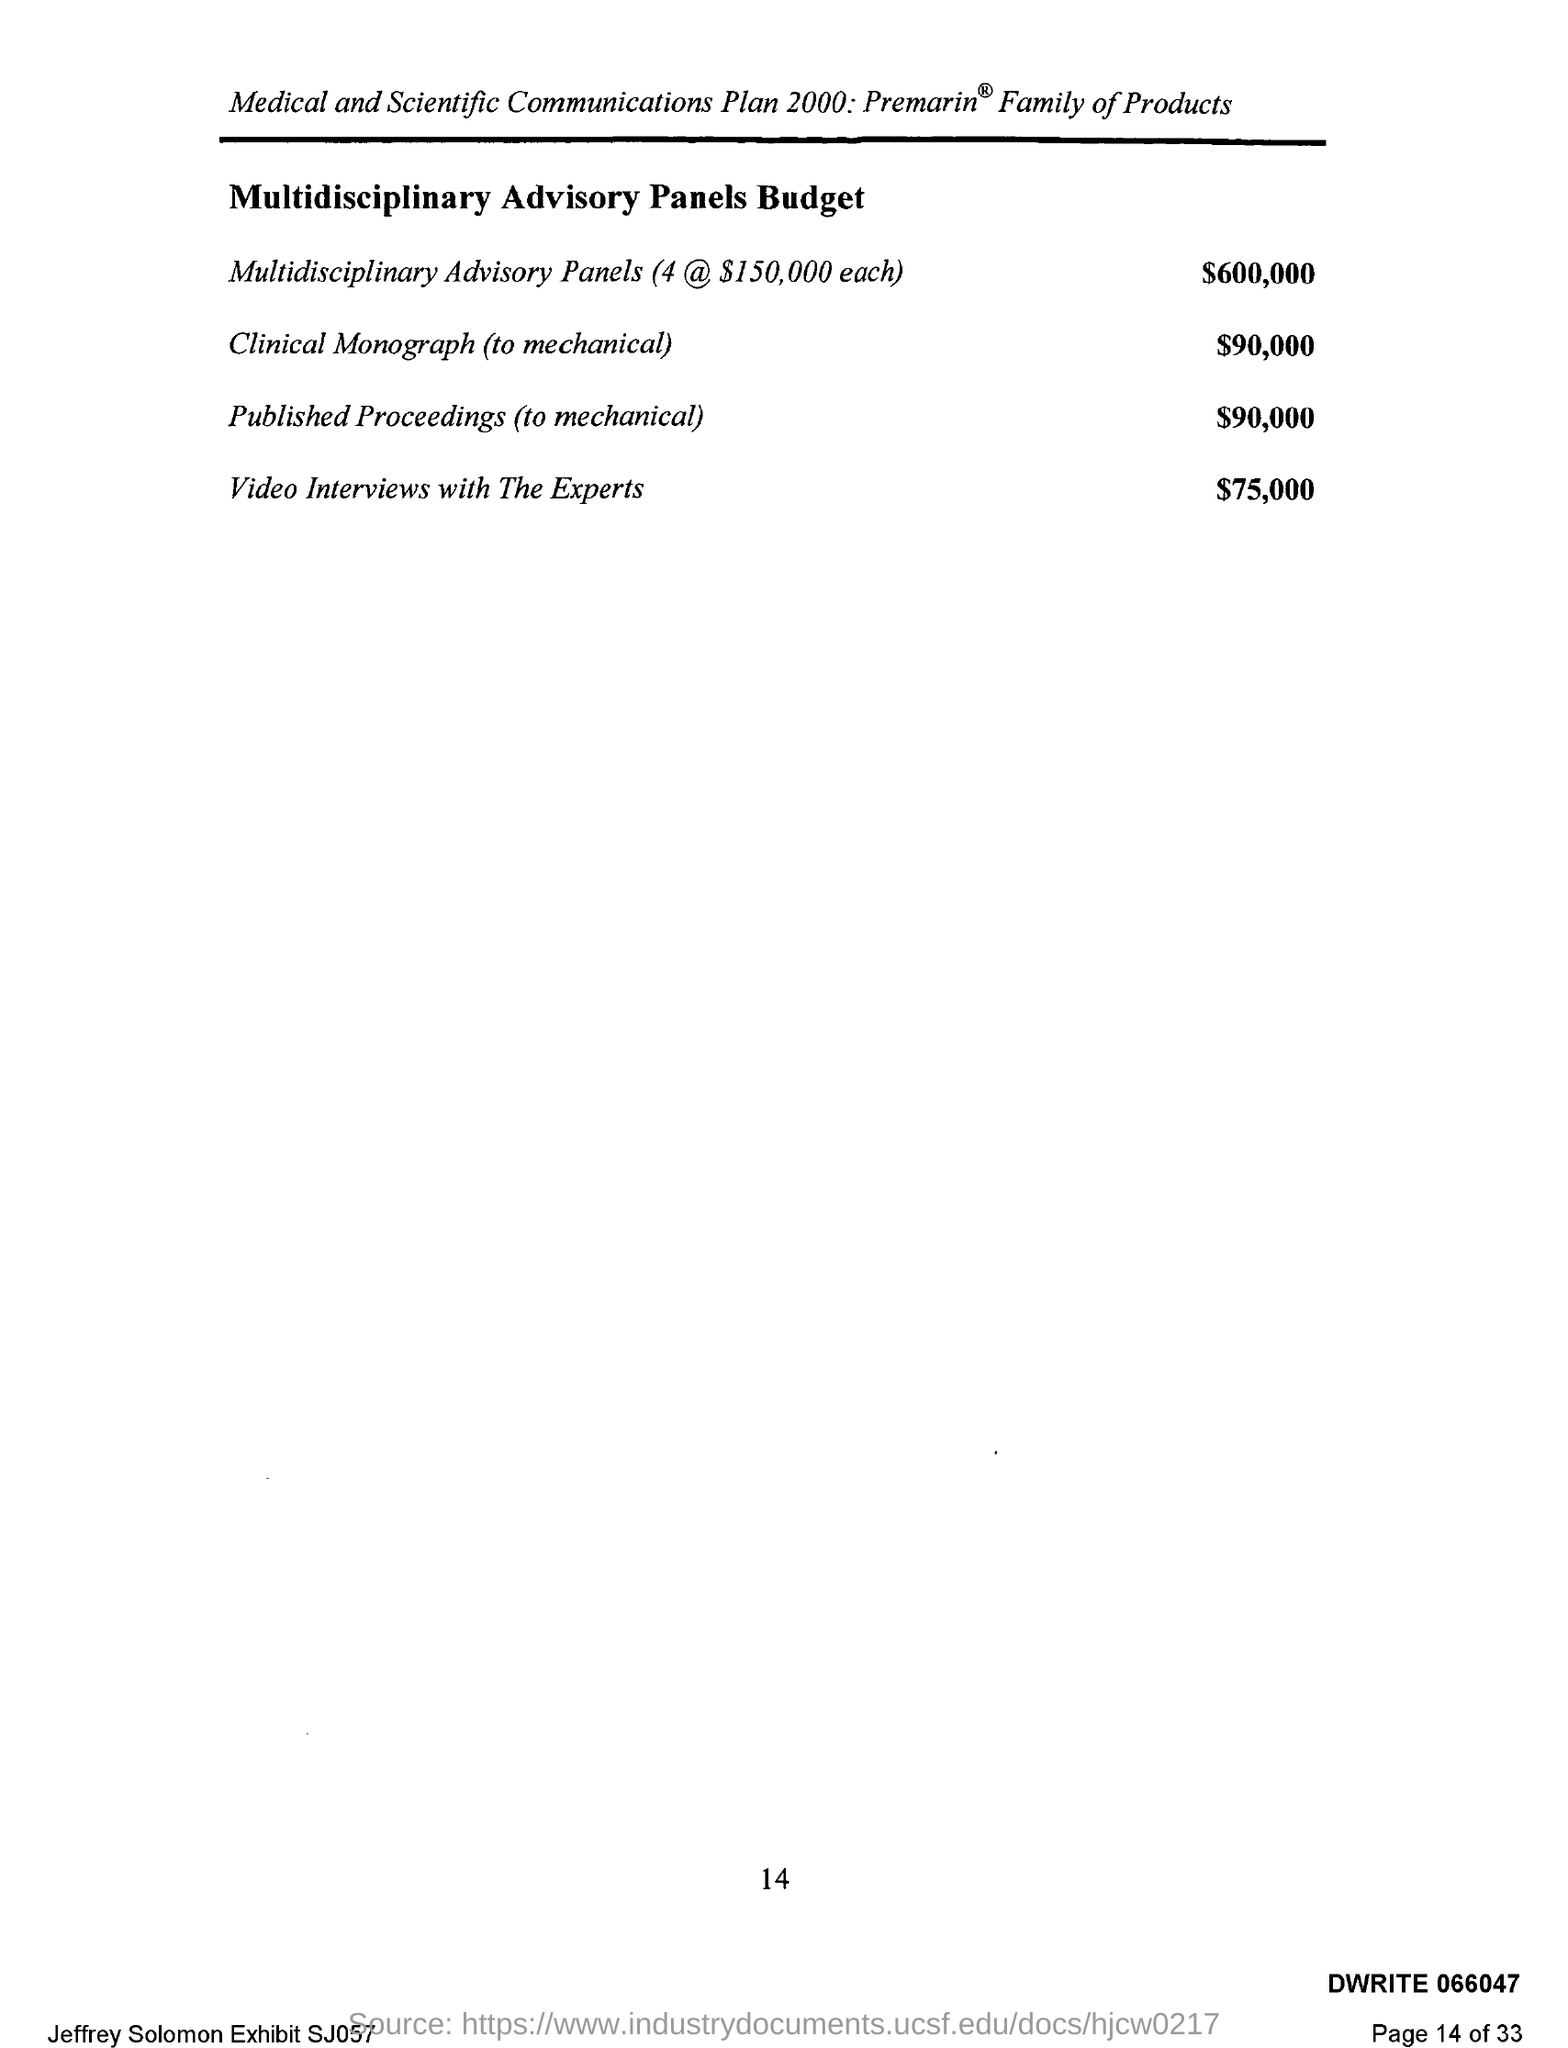Mention a couple of crucial points in this snapshot. The multidisciplinary advisory panel's budget for published proceedings related to mechanical topics is $90,000. The advisory panel's budget for video interviews with experts is $75,000. The Medical and Scientific Communications plan 2000 is named. The multidisciplinary advisory panel's budget for converting clinical monographs to mechanical format is $90,000. 